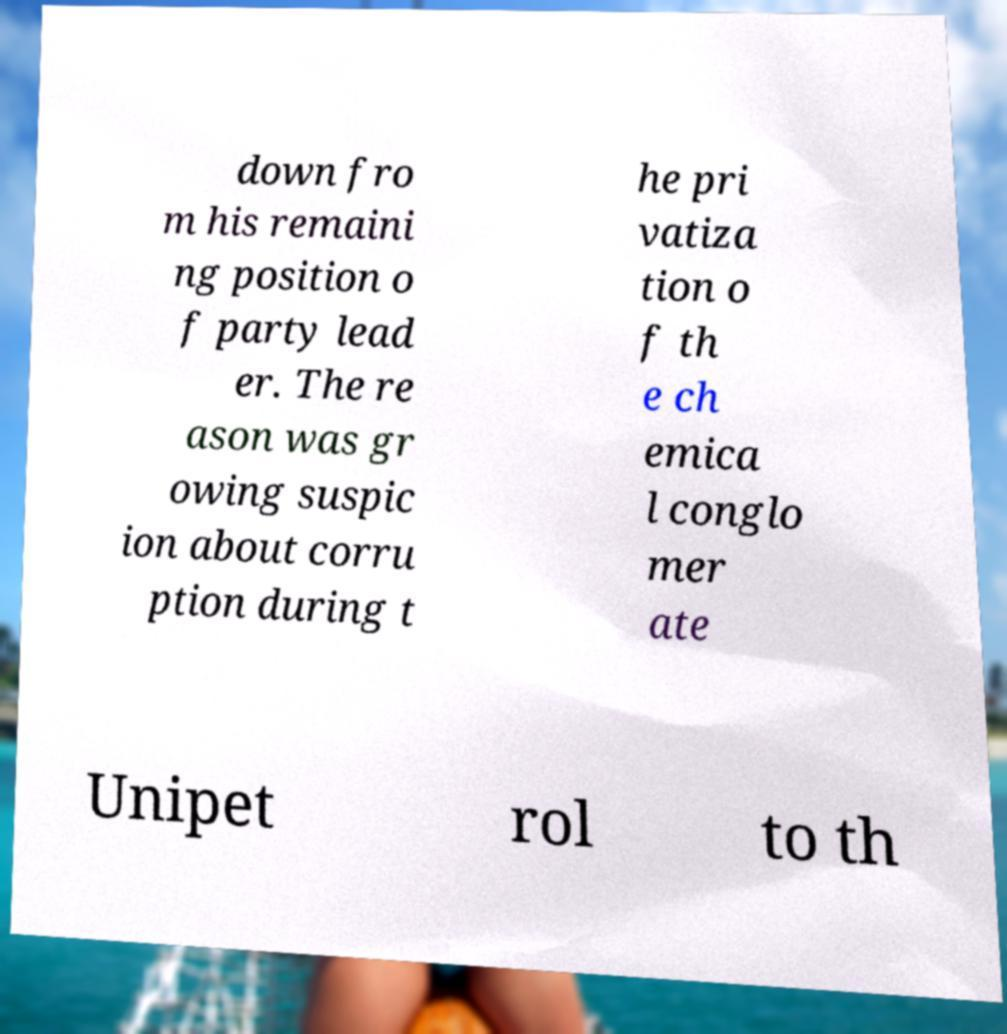I need the written content from this picture converted into text. Can you do that? down fro m his remaini ng position o f party lead er. The re ason was gr owing suspic ion about corru ption during t he pri vatiza tion o f th e ch emica l conglo mer ate Unipet rol to th 